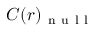Convert formula to latex. <formula><loc_0><loc_0><loc_500><loc_500>C ( r ) _ { n u l l }</formula> 